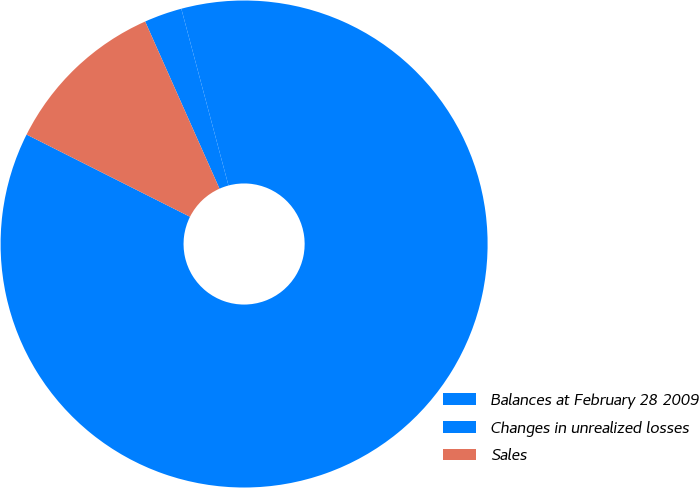<chart> <loc_0><loc_0><loc_500><loc_500><pie_chart><fcel>Balances at February 28 2009<fcel>Changes in unrealized losses<fcel>Sales<nl><fcel>86.57%<fcel>2.51%<fcel>10.92%<nl></chart> 